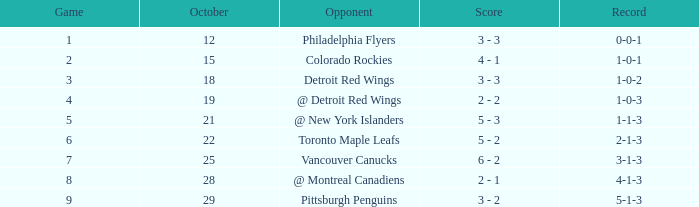Name the least game for record of 1-0-2 3.0. 